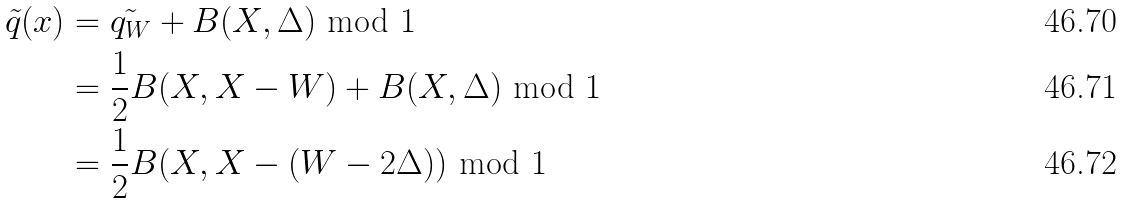<formula> <loc_0><loc_0><loc_500><loc_500>\tilde { q } ( x ) & = \tilde { q _ { W } } + B ( X , \Delta ) \text { mod } 1 \\ & = \frac { 1 } { 2 } B ( X , X - W ) + B ( X , \Delta ) \text { mod } 1 \\ & = \frac { 1 } { 2 } B ( X , X - ( W - 2 \Delta ) ) \text { mod } 1</formula> 